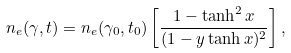<formula> <loc_0><loc_0><loc_500><loc_500>n _ { e } ( \gamma , t ) = n _ { e } ( \gamma _ { 0 } , t _ { 0 } ) \left [ \frac { 1 - \tanh ^ { 2 } x } { ( 1 - y \tanh x ) ^ { 2 } } \right ] ,</formula> 